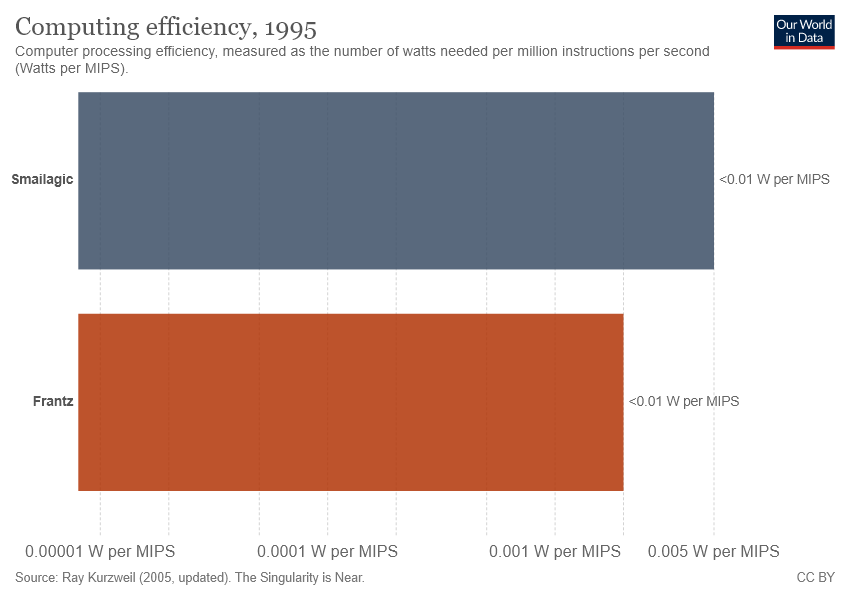Identify some key points in this picture. The label corresponding to the blue bar is "Smailagic. It is uncertain which player, Smailagic, has the highest computing efficiency. 